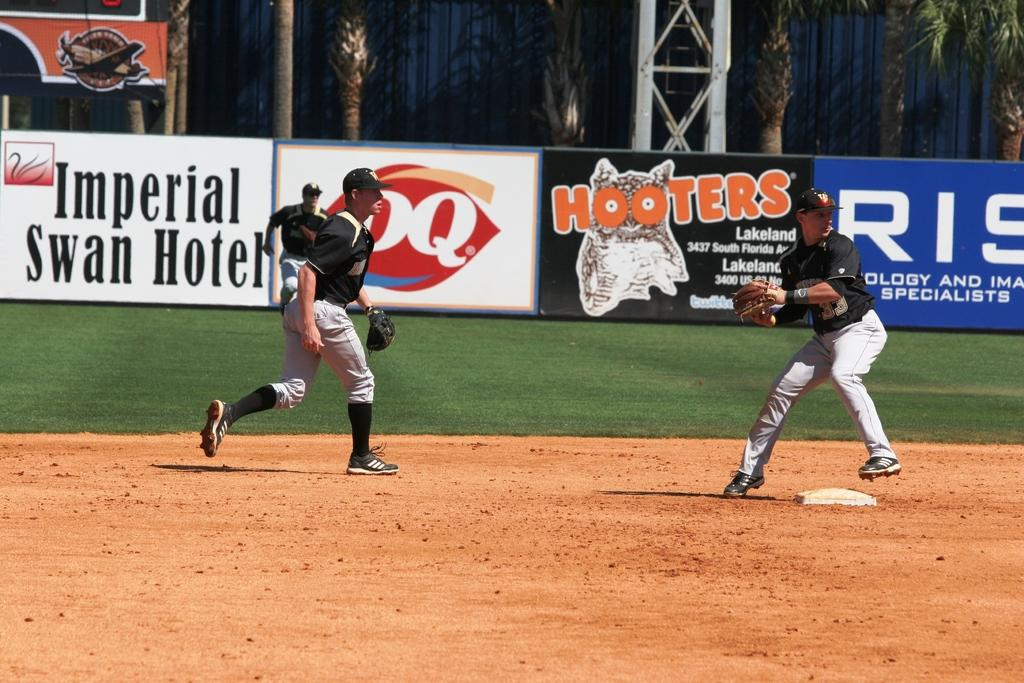<image>
Summarize the visual content of the image. A baseball game is being played, some of the sponsors include Hooters and Dairy Queen. 